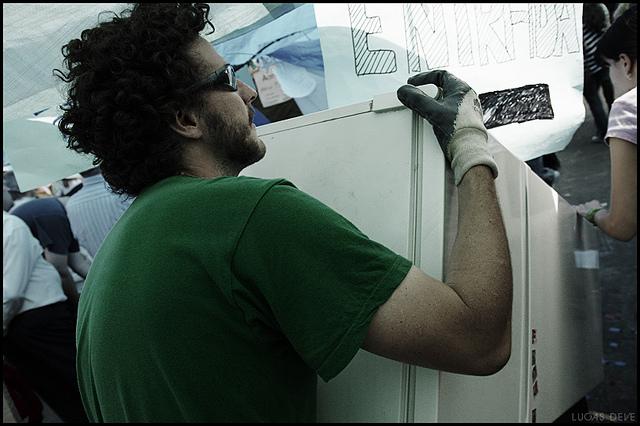Which hand has a glove on?
Keep it brief. Right. Is the item being carried heavy?
Concise answer only. Yes. What are they carrying?
Be succinct. Refrigerator. 